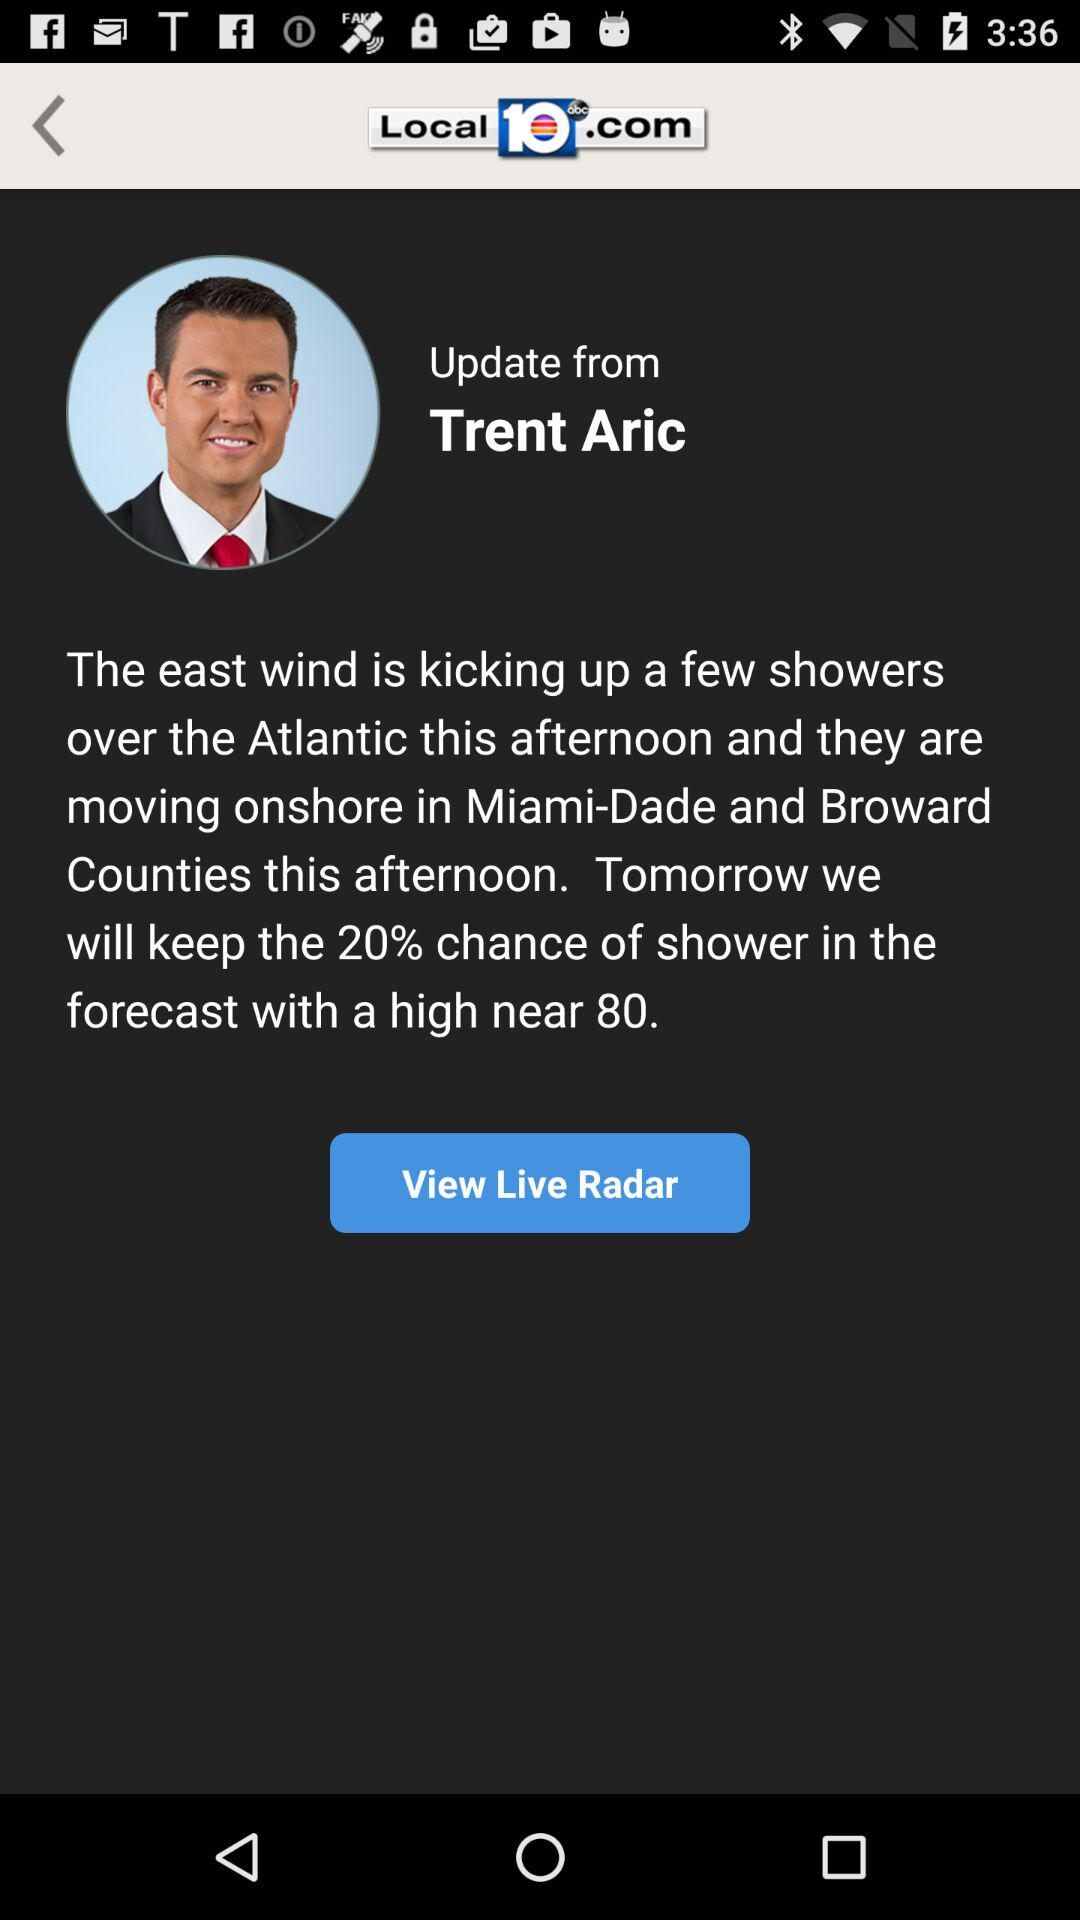What is the name of the meteorologist? The name of the meteorologist is Trent Aric. 